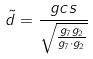<formula> <loc_0><loc_0><loc_500><loc_500>\tilde { d } = \frac { g c s } { \sqrt { \frac { g _ { 7 } g _ { 2 } } { g _ { 7 } \cdot g _ { 2 } } } }</formula> 